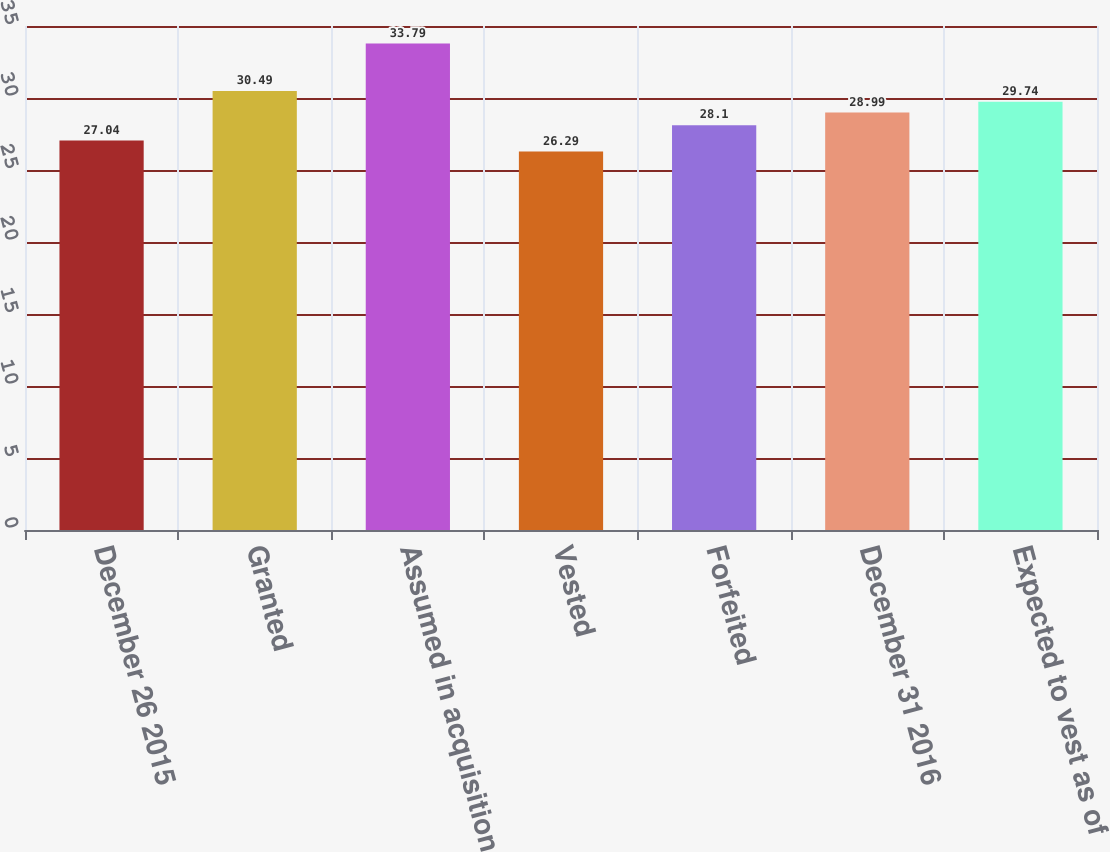<chart> <loc_0><loc_0><loc_500><loc_500><bar_chart><fcel>December 26 2015<fcel>Granted<fcel>Assumed in acquisition<fcel>Vested<fcel>Forfeited<fcel>December 31 2016<fcel>Expected to vest as of<nl><fcel>27.04<fcel>30.49<fcel>33.79<fcel>26.29<fcel>28.1<fcel>28.99<fcel>29.74<nl></chart> 